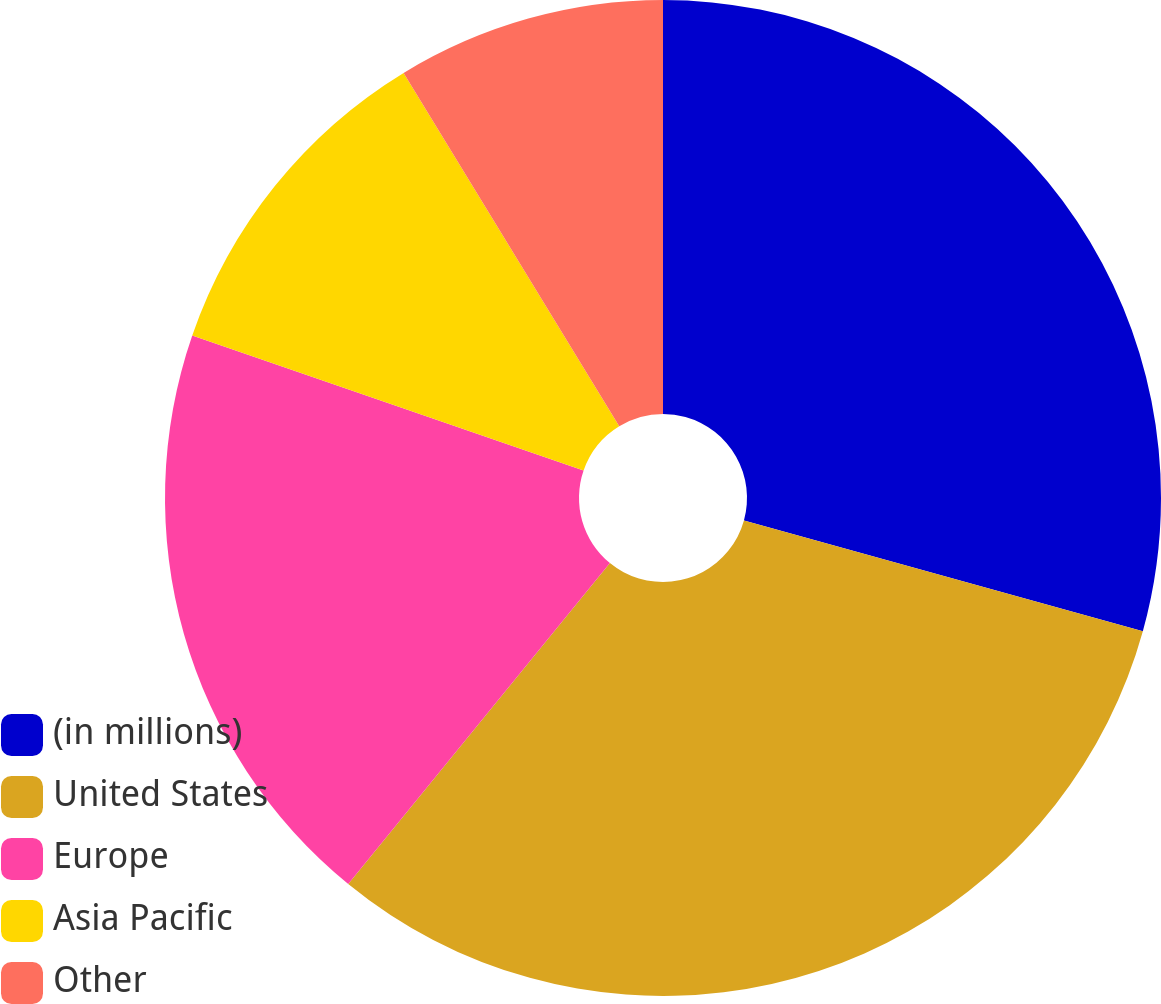Convert chart. <chart><loc_0><loc_0><loc_500><loc_500><pie_chart><fcel>(in millions)<fcel>United States<fcel>Europe<fcel>Asia Pacific<fcel>Other<nl><fcel>29.31%<fcel>31.58%<fcel>19.4%<fcel>10.99%<fcel>8.72%<nl></chart> 